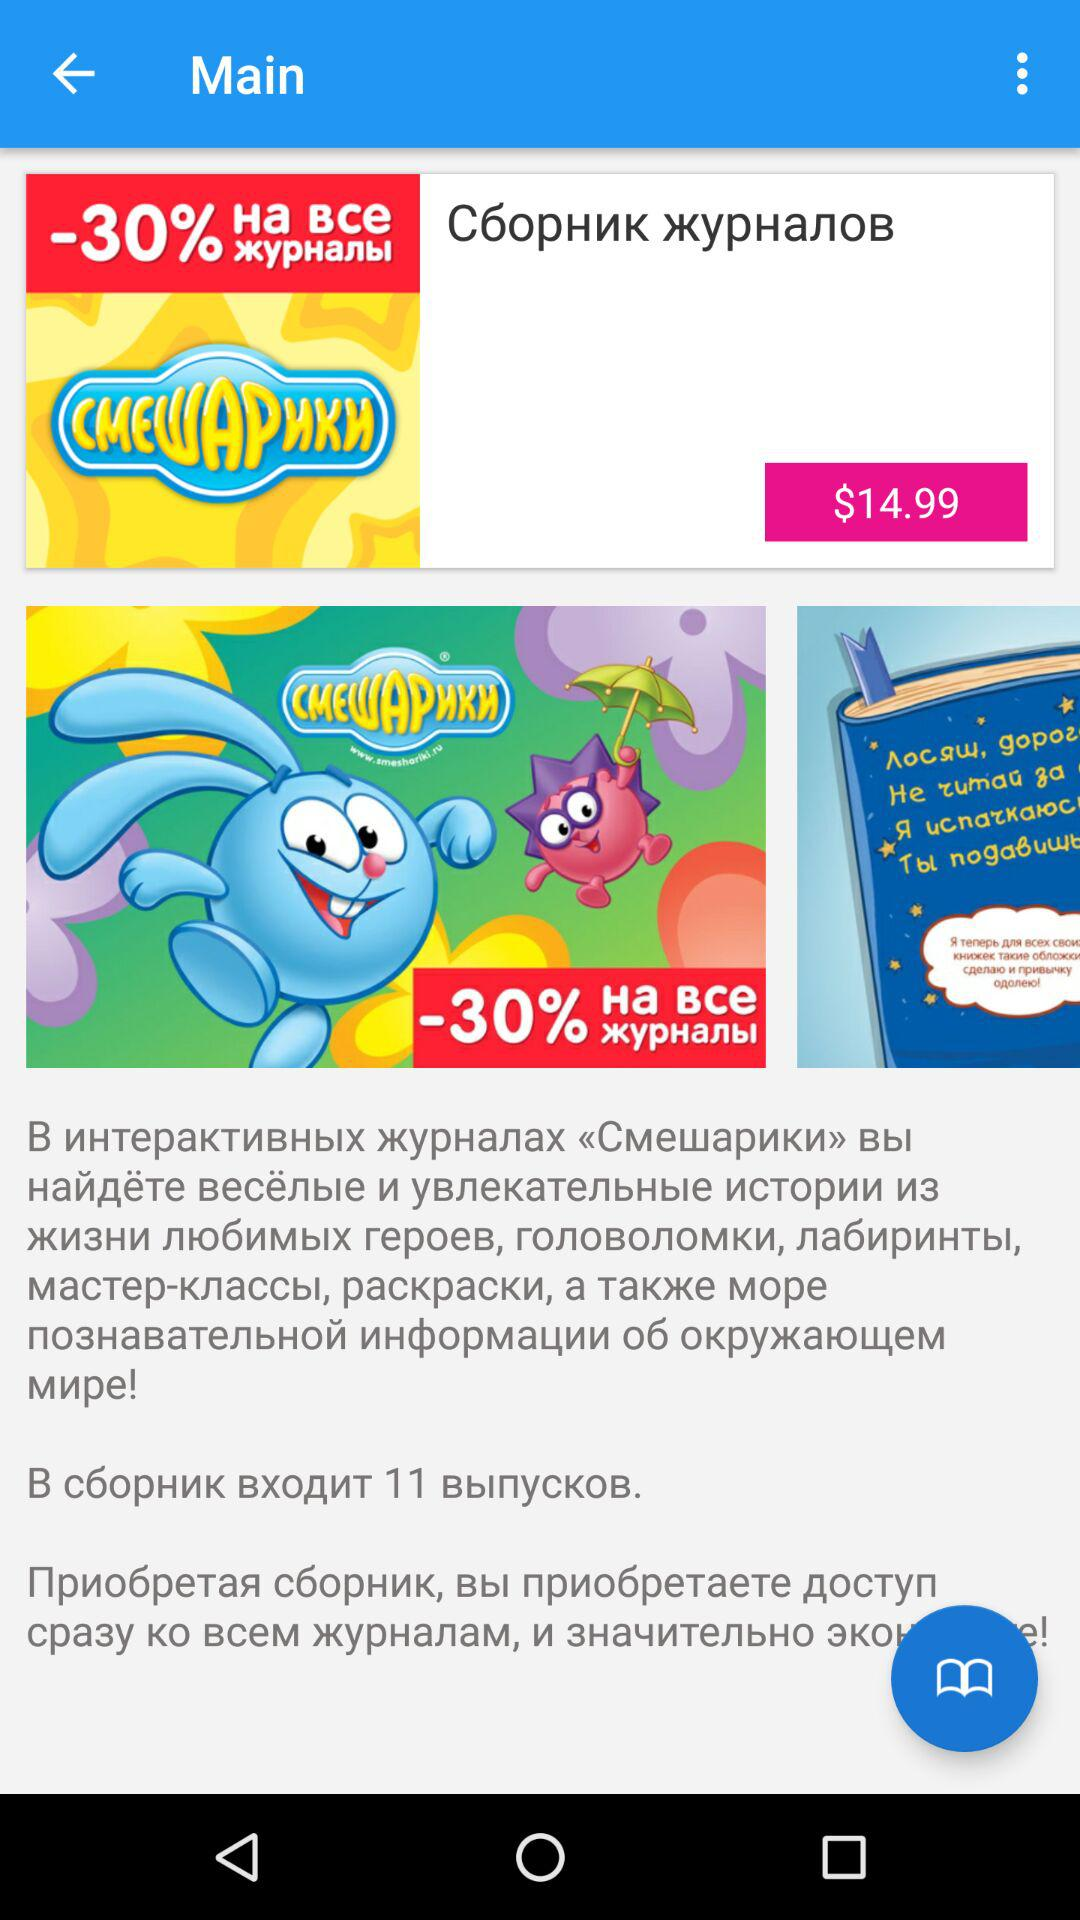How much is the discount on the magazine collection?
Answer the question using a single word or phrase. -30% 